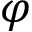Convert formula to latex. <formula><loc_0><loc_0><loc_500><loc_500>\varphi</formula> 